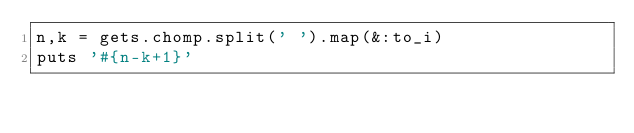Convert code to text. <code><loc_0><loc_0><loc_500><loc_500><_Ruby_>n,k = gets.chomp.split(' ').map(&:to_i)
puts '#{n-k+1}'</code> 